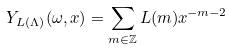Convert formula to latex. <formula><loc_0><loc_0><loc_500><loc_500>Y _ { L ( \Lambda ) } ( \omega , x ) = \sum _ { m \in \mathbb { Z } } L ( m ) x ^ { - m - 2 }</formula> 